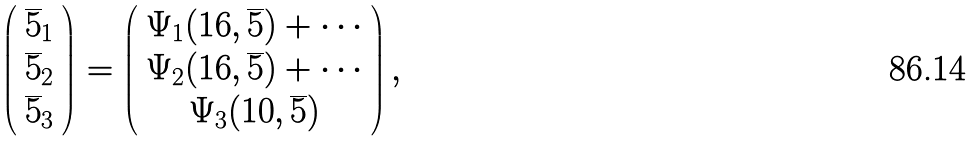Convert formula to latex. <formula><loc_0><loc_0><loc_500><loc_500>\left ( \begin{array} { c } { \overline { 5 } } _ { 1 } \\ { \overline { 5 } } _ { 2 } \\ { \overline { 5 } } _ { 3 } \end{array} \right ) = \left ( \begin{array} { c } \Psi _ { 1 } ( { 1 6 } , { \overline { 5 } } ) + \cdots \\ \Psi _ { 2 } ( { 1 6 } , { \overline { 5 } } ) + \cdots \\ \Psi _ { 3 } ( { 1 0 } , { \overline { 5 } } ) \end{array} \right ) ,</formula> 